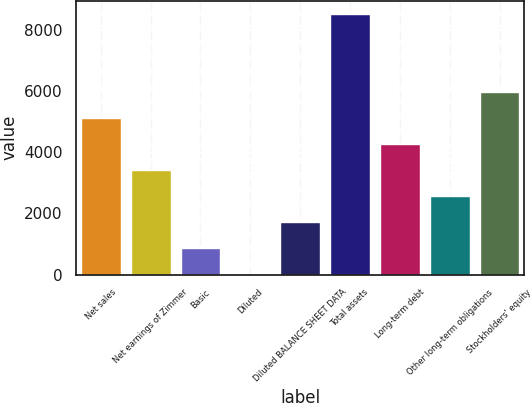<chart> <loc_0><loc_0><loc_500><loc_500><bar_chart><fcel>Net sales<fcel>Net earnings of Zimmer<fcel>Basic<fcel>Diluted<fcel>Diluted BALANCE SHEET DATA<fcel>Total assets<fcel>Long-term debt<fcel>Other long-term obligations<fcel>Stockholders' equity<nl><fcel>5110.81<fcel>3408.55<fcel>855.16<fcel>4.03<fcel>1706.29<fcel>8515.3<fcel>4259.68<fcel>2557.42<fcel>5961.94<nl></chart> 